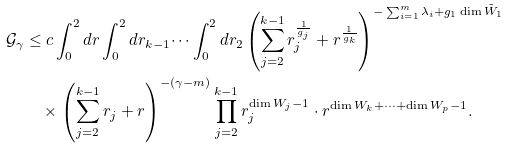<formula> <loc_0><loc_0><loc_500><loc_500>\mathcal { G } _ { \gamma } & \leq c \int _ { 0 } ^ { 2 } d r \int _ { 0 } ^ { 2 } d r _ { k - 1 } \dots \int _ { 0 } ^ { 2 } d r _ { 2 } \left ( \sum _ { j = 2 } ^ { k - 1 } r _ { j } ^ { \frac { 1 } { g _ { j } } } + r ^ { \frac { 1 } { g _ { k } } } \right ) ^ { - \sum _ { i = 1 } ^ { m } \lambda _ { i } + g _ { 1 } \dim \tilde { W } _ { 1 } } \\ & \quad \times \left ( \sum _ { j = 2 } ^ { k - 1 } r _ { j } + r \right ) ^ { - ( \gamma - m ) } \prod _ { j = 2 } ^ { k - 1 } r _ { j } ^ { \dim W _ { j } - 1 } \cdot r ^ { \dim W _ { k } + \dots + \dim W _ { p } - 1 } .</formula> 